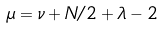<formula> <loc_0><loc_0><loc_500><loc_500>\mu = \nu + N / 2 + \lambda - 2</formula> 